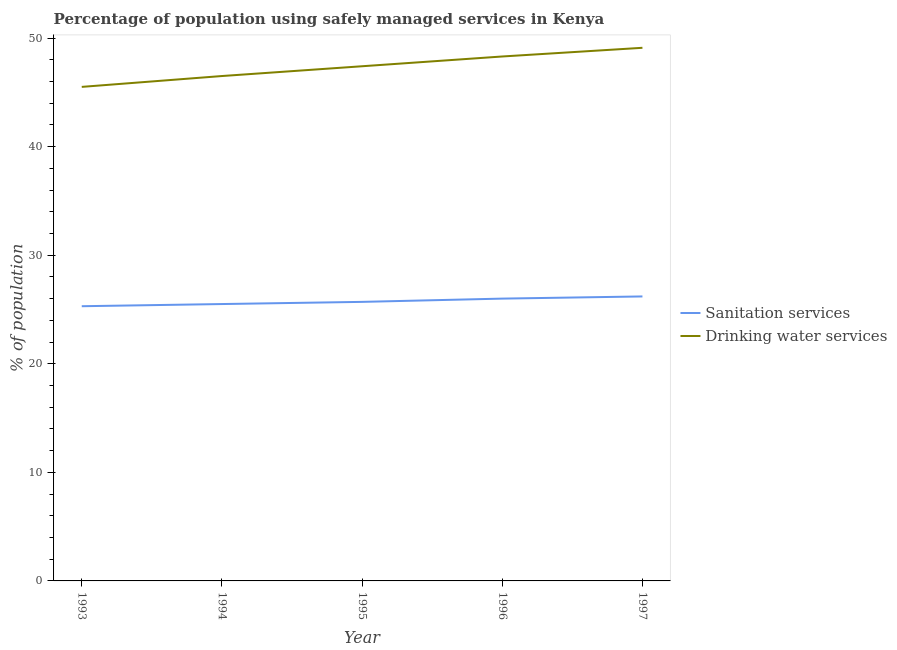What is the percentage of population who used sanitation services in 1995?
Your answer should be compact. 25.7. Across all years, what is the maximum percentage of population who used drinking water services?
Keep it short and to the point. 49.1. Across all years, what is the minimum percentage of population who used drinking water services?
Give a very brief answer. 45.5. What is the total percentage of population who used drinking water services in the graph?
Give a very brief answer. 236.8. What is the difference between the percentage of population who used sanitation services in 1994 and that in 1997?
Give a very brief answer. -0.7. What is the difference between the percentage of population who used sanitation services in 1996 and the percentage of population who used drinking water services in 1995?
Keep it short and to the point. -21.4. What is the average percentage of population who used sanitation services per year?
Provide a short and direct response. 25.74. In the year 1994, what is the difference between the percentage of population who used sanitation services and percentage of population who used drinking water services?
Ensure brevity in your answer.  -21. What is the ratio of the percentage of population who used drinking water services in 1994 to that in 1995?
Provide a succinct answer. 0.98. What is the difference between the highest and the second highest percentage of population who used drinking water services?
Ensure brevity in your answer.  0.8. What is the difference between the highest and the lowest percentage of population who used drinking water services?
Provide a short and direct response. 3.6. Is the percentage of population who used drinking water services strictly less than the percentage of population who used sanitation services over the years?
Make the answer very short. No. How many lines are there?
Your answer should be very brief. 2. How many years are there in the graph?
Your answer should be compact. 5. What is the difference between two consecutive major ticks on the Y-axis?
Provide a succinct answer. 10. Are the values on the major ticks of Y-axis written in scientific E-notation?
Provide a short and direct response. No. Does the graph contain any zero values?
Keep it short and to the point. No. Does the graph contain grids?
Your answer should be compact. No. Where does the legend appear in the graph?
Your answer should be very brief. Center right. What is the title of the graph?
Ensure brevity in your answer.  Percentage of population using safely managed services in Kenya. What is the label or title of the X-axis?
Make the answer very short. Year. What is the label or title of the Y-axis?
Offer a very short reply. % of population. What is the % of population of Sanitation services in 1993?
Your answer should be very brief. 25.3. What is the % of population of Drinking water services in 1993?
Make the answer very short. 45.5. What is the % of population of Sanitation services in 1994?
Give a very brief answer. 25.5. What is the % of population in Drinking water services in 1994?
Your response must be concise. 46.5. What is the % of population in Sanitation services in 1995?
Give a very brief answer. 25.7. What is the % of population in Drinking water services in 1995?
Your response must be concise. 47.4. What is the % of population of Sanitation services in 1996?
Make the answer very short. 26. What is the % of population in Drinking water services in 1996?
Ensure brevity in your answer.  48.3. What is the % of population in Sanitation services in 1997?
Provide a short and direct response. 26.2. What is the % of population in Drinking water services in 1997?
Make the answer very short. 49.1. Across all years, what is the maximum % of population of Sanitation services?
Keep it short and to the point. 26.2. Across all years, what is the maximum % of population of Drinking water services?
Make the answer very short. 49.1. Across all years, what is the minimum % of population in Sanitation services?
Provide a succinct answer. 25.3. Across all years, what is the minimum % of population of Drinking water services?
Keep it short and to the point. 45.5. What is the total % of population in Sanitation services in the graph?
Your answer should be very brief. 128.7. What is the total % of population of Drinking water services in the graph?
Provide a succinct answer. 236.8. What is the difference between the % of population in Sanitation services in 1993 and that in 1994?
Provide a short and direct response. -0.2. What is the difference between the % of population in Sanitation services in 1993 and that in 1997?
Provide a short and direct response. -0.9. What is the difference between the % of population in Drinking water services in 1993 and that in 1997?
Keep it short and to the point. -3.6. What is the difference between the % of population of Sanitation services in 1994 and that in 1995?
Offer a very short reply. -0.2. What is the difference between the % of population of Drinking water services in 1994 and that in 1995?
Your answer should be very brief. -0.9. What is the difference between the % of population in Sanitation services in 1994 and that in 1996?
Your answer should be very brief. -0.5. What is the difference between the % of population in Sanitation services in 1994 and that in 1997?
Offer a very short reply. -0.7. What is the difference between the % of population in Drinking water services in 1994 and that in 1997?
Provide a succinct answer. -2.6. What is the difference between the % of population in Sanitation services in 1995 and that in 1996?
Provide a succinct answer. -0.3. What is the difference between the % of population of Drinking water services in 1995 and that in 1996?
Provide a short and direct response. -0.9. What is the difference between the % of population in Drinking water services in 1996 and that in 1997?
Your response must be concise. -0.8. What is the difference between the % of population of Sanitation services in 1993 and the % of population of Drinking water services in 1994?
Your answer should be compact. -21.2. What is the difference between the % of population of Sanitation services in 1993 and the % of population of Drinking water services in 1995?
Offer a very short reply. -22.1. What is the difference between the % of population of Sanitation services in 1993 and the % of population of Drinking water services in 1996?
Offer a very short reply. -23. What is the difference between the % of population of Sanitation services in 1993 and the % of population of Drinking water services in 1997?
Give a very brief answer. -23.8. What is the difference between the % of population in Sanitation services in 1994 and the % of population in Drinking water services in 1995?
Your answer should be compact. -21.9. What is the difference between the % of population in Sanitation services in 1994 and the % of population in Drinking water services in 1996?
Offer a terse response. -22.8. What is the difference between the % of population in Sanitation services in 1994 and the % of population in Drinking water services in 1997?
Your answer should be very brief. -23.6. What is the difference between the % of population of Sanitation services in 1995 and the % of population of Drinking water services in 1996?
Make the answer very short. -22.6. What is the difference between the % of population in Sanitation services in 1995 and the % of population in Drinking water services in 1997?
Your answer should be very brief. -23.4. What is the difference between the % of population of Sanitation services in 1996 and the % of population of Drinking water services in 1997?
Offer a very short reply. -23.1. What is the average % of population in Sanitation services per year?
Your answer should be very brief. 25.74. What is the average % of population in Drinking water services per year?
Offer a terse response. 47.36. In the year 1993, what is the difference between the % of population of Sanitation services and % of population of Drinking water services?
Offer a terse response. -20.2. In the year 1994, what is the difference between the % of population in Sanitation services and % of population in Drinking water services?
Give a very brief answer. -21. In the year 1995, what is the difference between the % of population of Sanitation services and % of population of Drinking water services?
Your answer should be compact. -21.7. In the year 1996, what is the difference between the % of population of Sanitation services and % of population of Drinking water services?
Your response must be concise. -22.3. In the year 1997, what is the difference between the % of population in Sanitation services and % of population in Drinking water services?
Your answer should be very brief. -22.9. What is the ratio of the % of population of Sanitation services in 1993 to that in 1994?
Offer a very short reply. 0.99. What is the ratio of the % of population of Drinking water services in 1993 to that in 1994?
Your answer should be compact. 0.98. What is the ratio of the % of population of Sanitation services in 1993 to that in 1995?
Provide a succinct answer. 0.98. What is the ratio of the % of population in Drinking water services in 1993 to that in 1995?
Your answer should be very brief. 0.96. What is the ratio of the % of population in Sanitation services in 1993 to that in 1996?
Your answer should be compact. 0.97. What is the ratio of the % of population in Drinking water services in 1993 to that in 1996?
Provide a succinct answer. 0.94. What is the ratio of the % of population in Sanitation services in 1993 to that in 1997?
Offer a terse response. 0.97. What is the ratio of the % of population in Drinking water services in 1993 to that in 1997?
Give a very brief answer. 0.93. What is the ratio of the % of population in Drinking water services in 1994 to that in 1995?
Keep it short and to the point. 0.98. What is the ratio of the % of population in Sanitation services in 1994 to that in 1996?
Give a very brief answer. 0.98. What is the ratio of the % of population in Drinking water services in 1994 to that in 1996?
Your answer should be very brief. 0.96. What is the ratio of the % of population in Sanitation services in 1994 to that in 1997?
Ensure brevity in your answer.  0.97. What is the ratio of the % of population in Drinking water services in 1994 to that in 1997?
Offer a very short reply. 0.95. What is the ratio of the % of population of Sanitation services in 1995 to that in 1996?
Make the answer very short. 0.99. What is the ratio of the % of population in Drinking water services in 1995 to that in 1996?
Your answer should be compact. 0.98. What is the ratio of the % of population in Sanitation services in 1995 to that in 1997?
Provide a short and direct response. 0.98. What is the ratio of the % of population of Drinking water services in 1995 to that in 1997?
Offer a very short reply. 0.97. What is the ratio of the % of population of Sanitation services in 1996 to that in 1997?
Make the answer very short. 0.99. What is the ratio of the % of population of Drinking water services in 1996 to that in 1997?
Your answer should be compact. 0.98. What is the difference between the highest and the second highest % of population in Drinking water services?
Keep it short and to the point. 0.8. What is the difference between the highest and the lowest % of population of Sanitation services?
Ensure brevity in your answer.  0.9. 